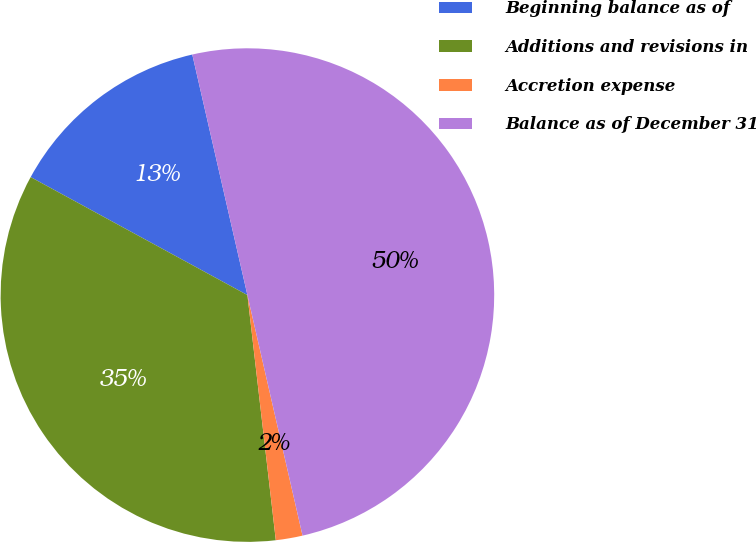<chart> <loc_0><loc_0><loc_500><loc_500><pie_chart><fcel>Beginning balance as of<fcel>Additions and revisions in<fcel>Accretion expense<fcel>Balance as of December 31<nl><fcel>13.48%<fcel>34.77%<fcel>1.75%<fcel>50.0%<nl></chart> 